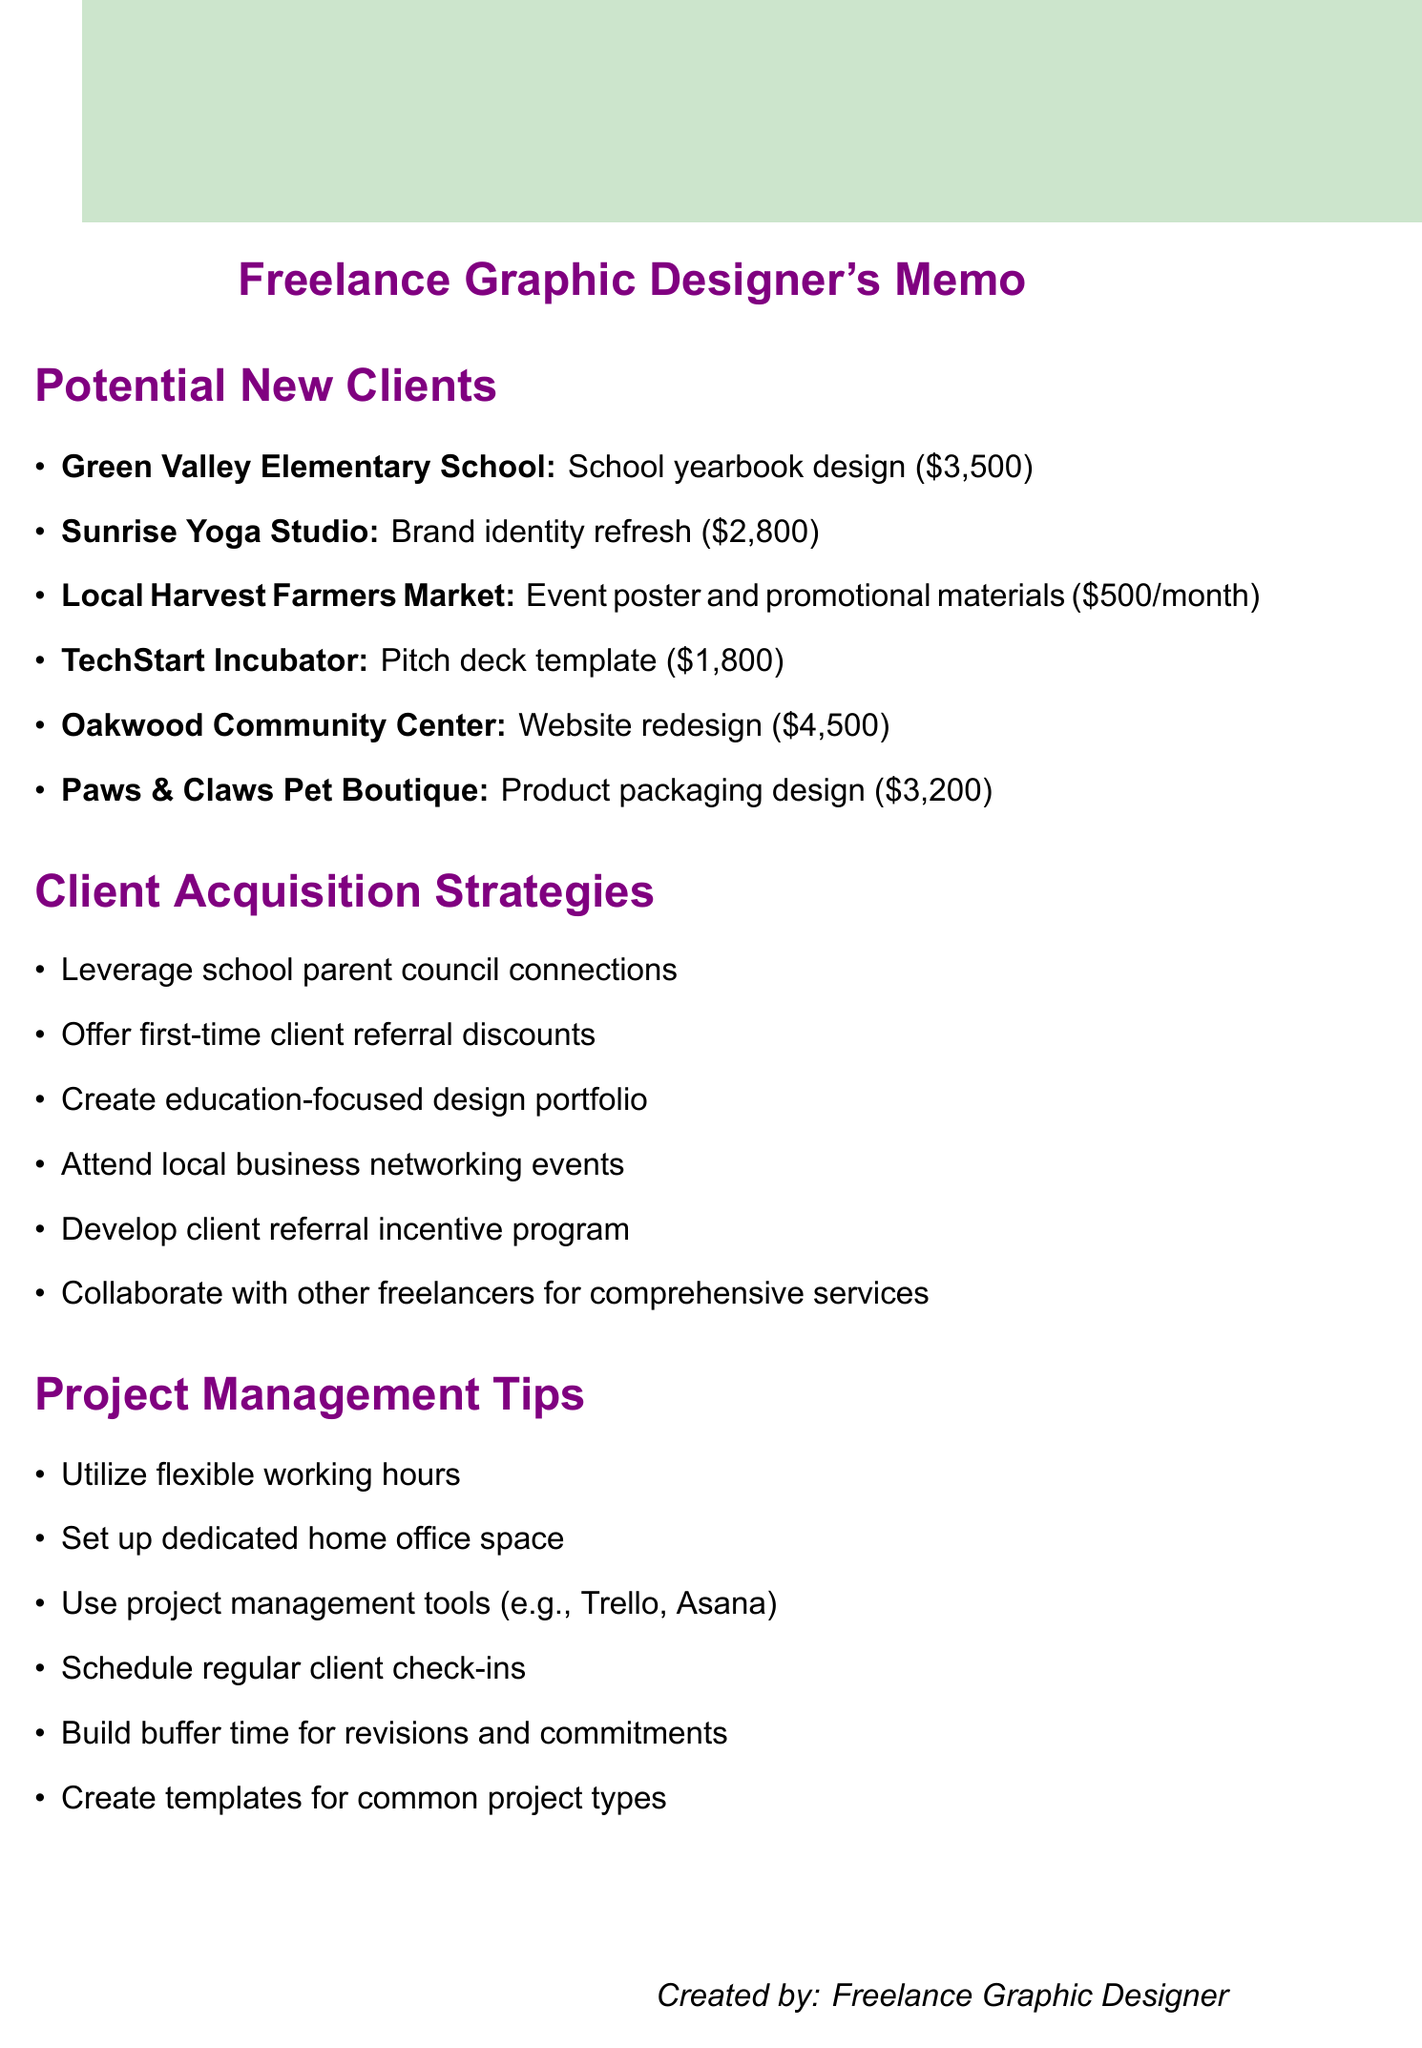What is the project type for Green Valley Elementary School? The project type is specified in the document under the potential clients section, listing the project for Green Valley Elementary School.
Answer: School yearbook design What is the budget for the Oakwood Community Center project? The budget for the Oakwood Community Center is mentioned along with its project details.
Answer: $4,500 What is the deadline for the Sunrise Yoga Studio project? The deadline for the Sunrise Yoga Studio project is listed under the potential clients section.
Answer: 6 weeks How many projects have a budget of $3,200 or more? This requires counting the projects that meet the budget criteria within the document, which are Oakwood Community Center and Paws & Claws Pet Boutique.
Answer: 2 Which strategy involves working with other freelancers? The document specifies multiple strategies for client acquisition, including collaboration with other professionals.
Answer: Collaborate with other freelancers for comprehensive services What is one of the project management tips listed in the document? The document outlines various project management tips, and this will retrieve one of them.
Answer: Utilize flexible working hours Which client requested a website redesign? This information can be retrieved from the potential clients section identifying the client needing the specific project type.
Answer: Oakwood Community Center What is the project type for Local Harvest Farmers Market? This is a straightforward retrieval question regarding the type of project for the specified client.
Answer: Event poster and promotional materials How often are deliverables required for the Local Harvest Farmers Market project? The document specifies the frequency of project deliverables for this client.
Answer: Ongoing, monthly deliverables 